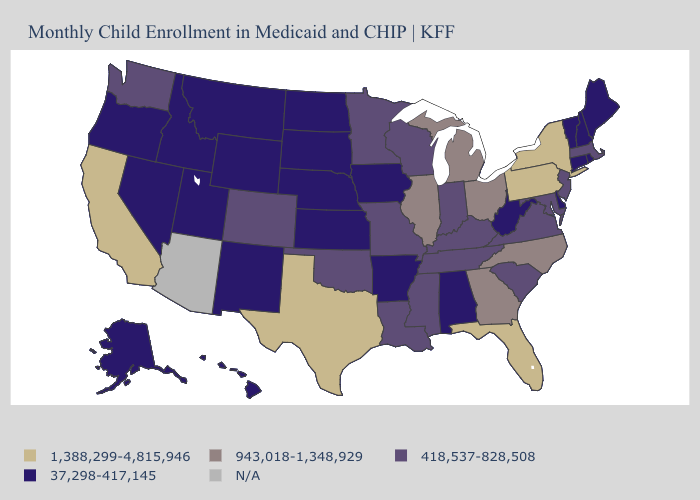Name the states that have a value in the range 943,018-1,348,929?
Keep it brief. Georgia, Illinois, Michigan, North Carolina, Ohio. What is the value of Wyoming?
Answer briefly. 37,298-417,145. Which states have the highest value in the USA?
Quick response, please. California, Florida, New York, Pennsylvania, Texas. Which states have the highest value in the USA?
Be succinct. California, Florida, New York, Pennsylvania, Texas. Is the legend a continuous bar?
Give a very brief answer. No. Name the states that have a value in the range 418,537-828,508?
Keep it brief. Colorado, Indiana, Kentucky, Louisiana, Maryland, Massachusetts, Minnesota, Mississippi, Missouri, New Jersey, Oklahoma, South Carolina, Tennessee, Virginia, Washington, Wisconsin. Which states have the lowest value in the USA?
Keep it brief. Alabama, Alaska, Arkansas, Connecticut, Delaware, Hawaii, Idaho, Iowa, Kansas, Maine, Montana, Nebraska, Nevada, New Hampshire, New Mexico, North Dakota, Oregon, Rhode Island, South Dakota, Utah, Vermont, West Virginia, Wyoming. Name the states that have a value in the range 418,537-828,508?
Keep it brief. Colorado, Indiana, Kentucky, Louisiana, Maryland, Massachusetts, Minnesota, Mississippi, Missouri, New Jersey, Oklahoma, South Carolina, Tennessee, Virginia, Washington, Wisconsin. Name the states that have a value in the range 1,388,299-4,815,946?
Short answer required. California, Florida, New York, Pennsylvania, Texas. What is the value of Indiana?
Keep it brief. 418,537-828,508. What is the value of Oklahoma?
Give a very brief answer. 418,537-828,508. What is the value of Alabama?
Short answer required. 37,298-417,145. What is the highest value in states that border Arizona?
Quick response, please. 1,388,299-4,815,946. Among the states that border Idaho , does Wyoming have the highest value?
Keep it brief. No. What is the value of West Virginia?
Be succinct. 37,298-417,145. 